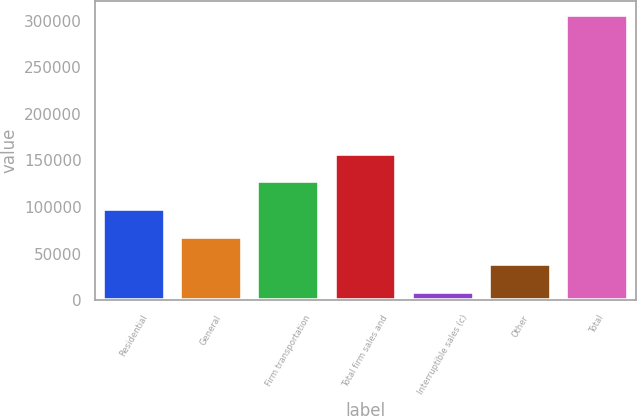Convert chart. <chart><loc_0><loc_0><loc_500><loc_500><bar_chart><fcel>Residential<fcel>General<fcel>Firm transportation<fcel>Total firm sales and<fcel>Interruptible sales (c)<fcel>Other<fcel>Total<nl><fcel>97887.5<fcel>68244<fcel>127531<fcel>157174<fcel>8957<fcel>38600.5<fcel>305392<nl></chart> 